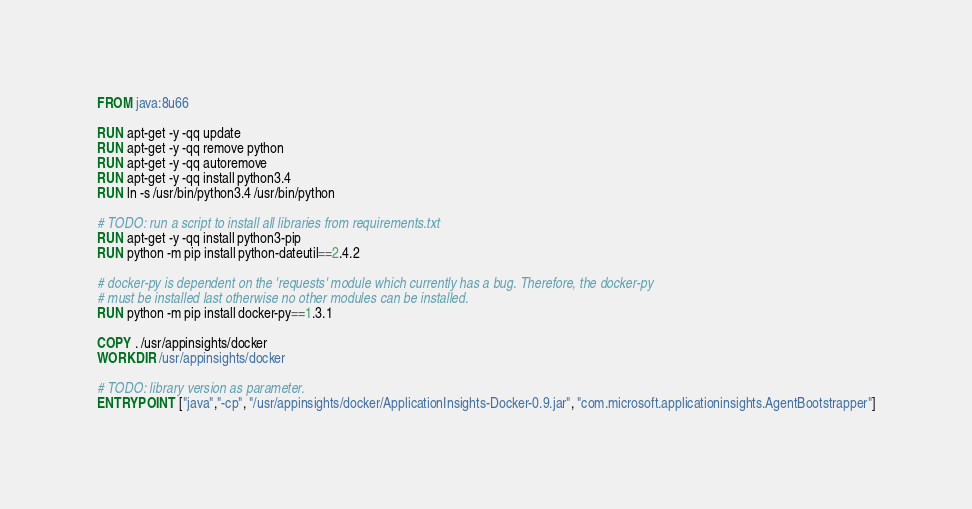Convert code to text. <code><loc_0><loc_0><loc_500><loc_500><_Dockerfile_>FROM java:8u66

RUN apt-get -y -qq update
RUN apt-get -y -qq remove python
RUN apt-get -y -qq autoremove
RUN apt-get -y -qq install python3.4
RUN ln -s /usr/bin/python3.4 /usr/bin/python

# TODO: run a script to install all libraries from requirements.txt
RUN apt-get -y -qq install python3-pip
RUN python -m pip install python-dateutil==2.4.2

# docker-py is dependent on the 'requests' module which currently has a bug. Therefore, the docker-py
# must be installed last otherwise no other modules can be installed.
RUN python -m pip install docker-py==1.3.1

COPY . /usr/appinsights/docker
WORKDIR /usr/appinsights/docker

# TODO: library version as parameter.
ENTRYPOINT ["java","-cp", "/usr/appinsights/docker/ApplicationInsights-Docker-0.9.jar", "com.microsoft.applicationinsights.AgentBootstrapper"]</code> 